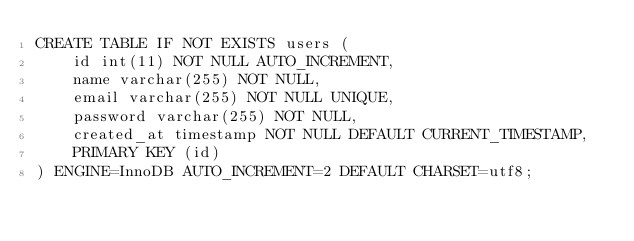<code> <loc_0><loc_0><loc_500><loc_500><_SQL_>CREATE TABLE IF NOT EXISTS users (
    id int(11) NOT NULL AUTO_INCREMENT,
    name varchar(255) NOT NULL,
    email varchar(255) NOT NULL UNIQUE,
    password varchar(255) NOT NULL,
    created_at timestamp NOT NULL DEFAULT CURRENT_TIMESTAMP,
    PRIMARY KEY (id)
) ENGINE=InnoDB AUTO_INCREMENT=2 DEFAULT CHARSET=utf8;</code> 